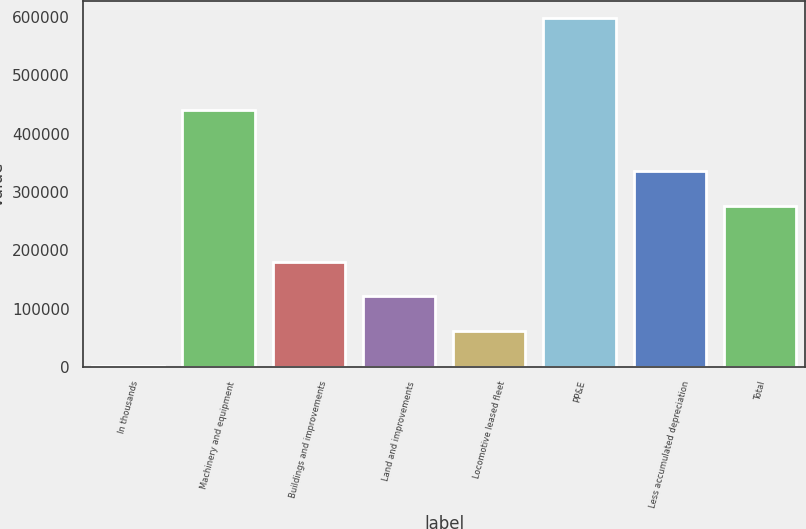<chart> <loc_0><loc_0><loc_500><loc_500><bar_chart><fcel>In thousands<fcel>Machinery and equipment<fcel>Buildings and improvements<fcel>Land and improvements<fcel>Locomotive leased fleet<fcel>PP&E<fcel>Less accumulated depreciation<fcel>Total<nl><fcel>2013<fcel>440297<fcel>180731<fcel>121158<fcel>61585.7<fcel>597740<fcel>335651<fcel>276078<nl></chart> 